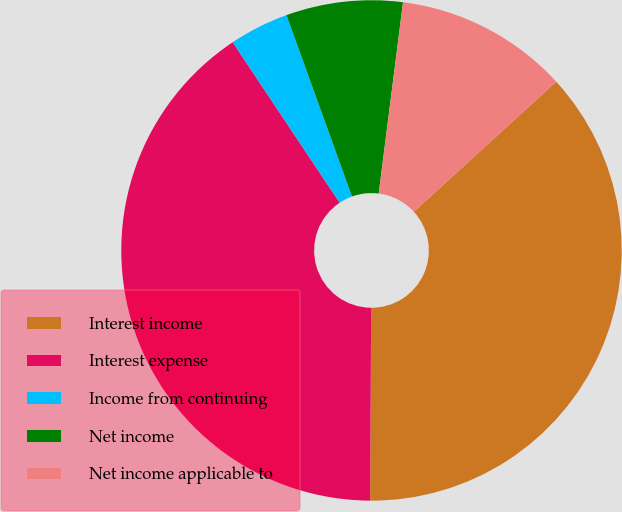Convert chart. <chart><loc_0><loc_0><loc_500><loc_500><pie_chart><fcel>Interest income<fcel>Interest expense<fcel>Income from continuing<fcel>Net income<fcel>Net income applicable to<nl><fcel>36.87%<fcel>40.56%<fcel>3.84%<fcel>7.53%<fcel>11.21%<nl></chart> 